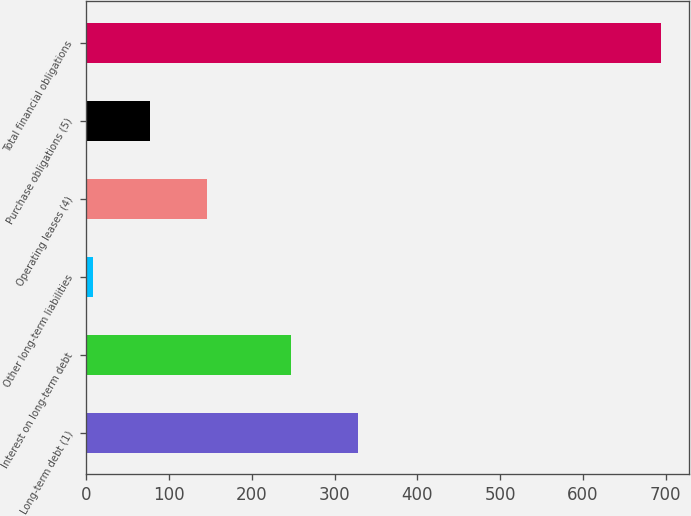<chart> <loc_0><loc_0><loc_500><loc_500><bar_chart><fcel>Long-term debt (1)<fcel>Interest on long-term debt<fcel>Other long-term liabilities<fcel>Operating leases (4)<fcel>Purchase obligations (5)<fcel>Total financial obligations<nl><fcel>328.2<fcel>247.8<fcel>8.2<fcel>145.38<fcel>76.79<fcel>694.1<nl></chart> 